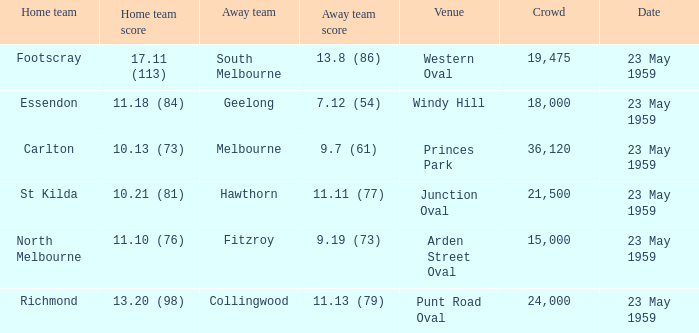What was the home team's score at the game held at Punt Road Oval? 13.20 (98). 